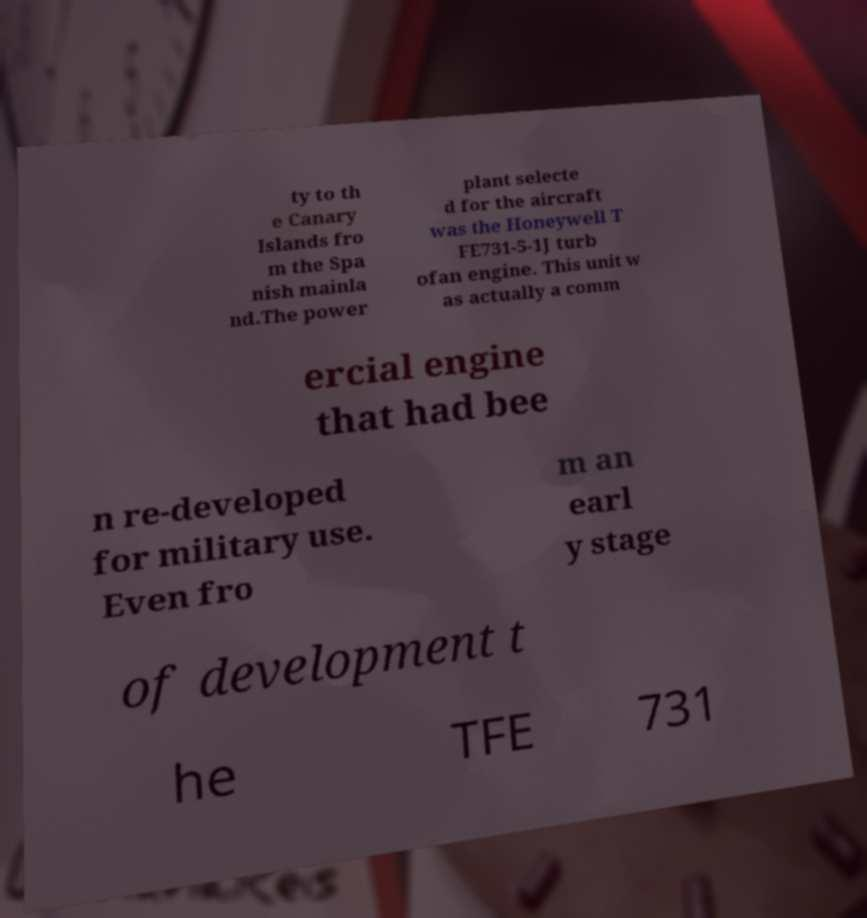Please identify and transcribe the text found in this image. ty to th e Canary Islands fro m the Spa nish mainla nd.The power plant selecte d for the aircraft was the Honeywell T FE731-5-1J turb ofan engine. This unit w as actually a comm ercial engine that had bee n re-developed for military use. Even fro m an earl y stage of development t he TFE 731 